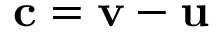Convert formula to latex. <formula><loc_0><loc_0><loc_500><loc_500>\mathbf c = \mathbf v - \mathbf u</formula> 